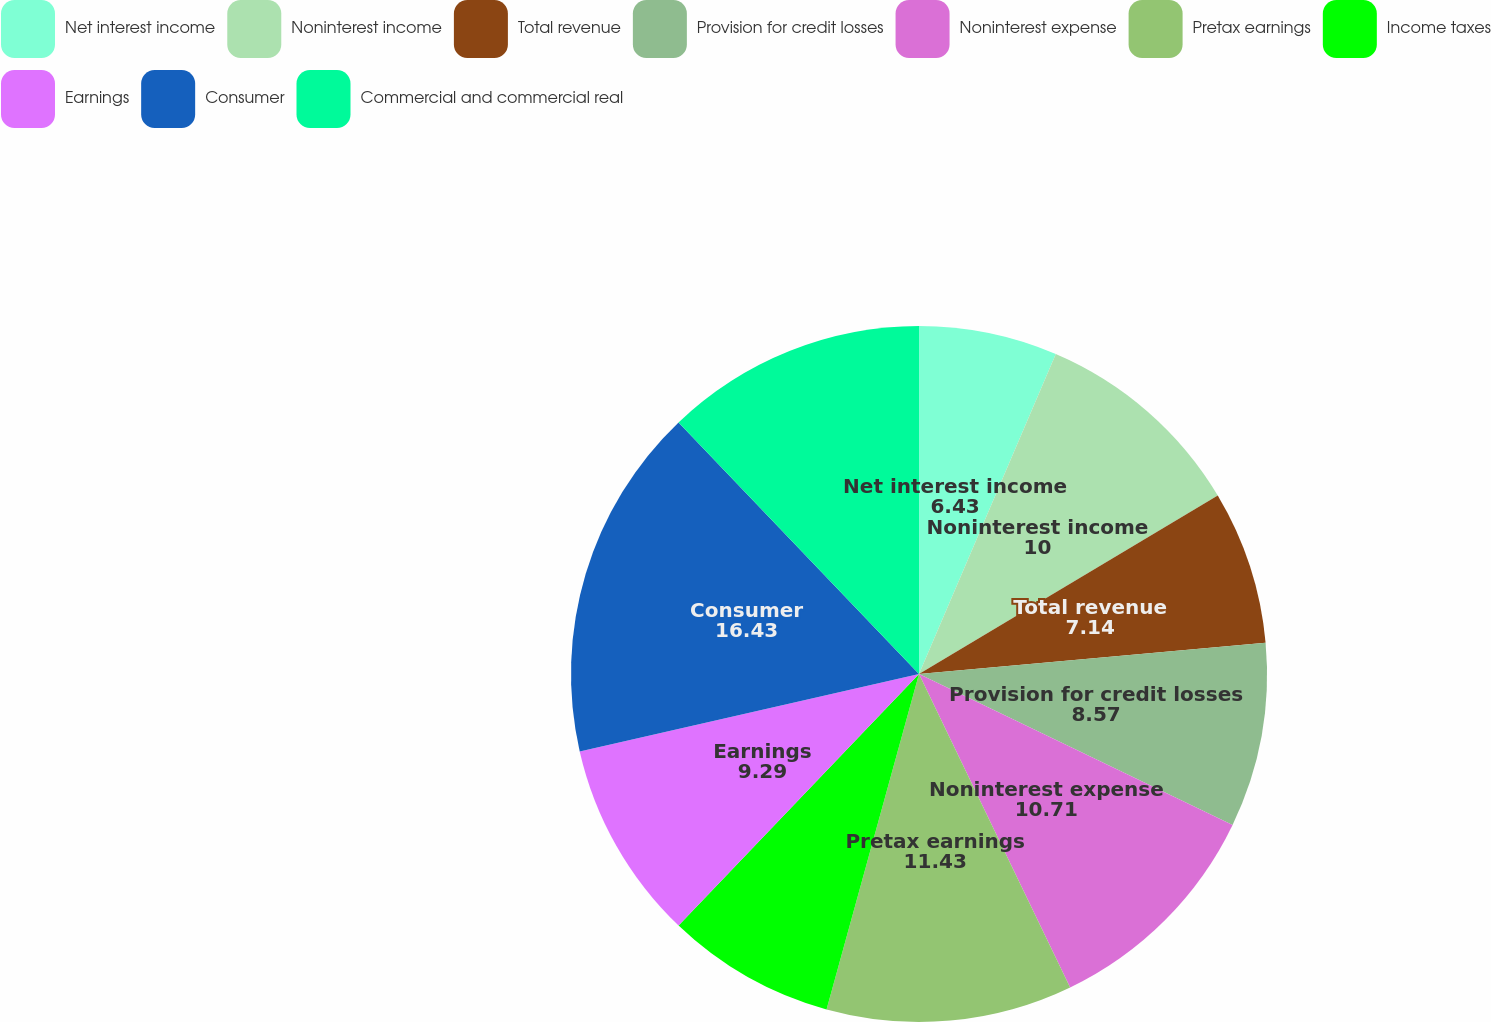Convert chart. <chart><loc_0><loc_0><loc_500><loc_500><pie_chart><fcel>Net interest income<fcel>Noninterest income<fcel>Total revenue<fcel>Provision for credit losses<fcel>Noninterest expense<fcel>Pretax earnings<fcel>Income taxes<fcel>Earnings<fcel>Consumer<fcel>Commercial and commercial real<nl><fcel>6.43%<fcel>10.0%<fcel>7.14%<fcel>8.57%<fcel>10.71%<fcel>11.43%<fcel>7.86%<fcel>9.29%<fcel>16.43%<fcel>12.14%<nl></chart> 